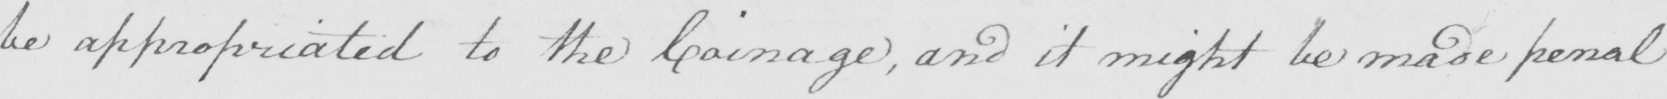What text is written in this handwritten line? be appropriated to the Coinage , and it might be made penal 